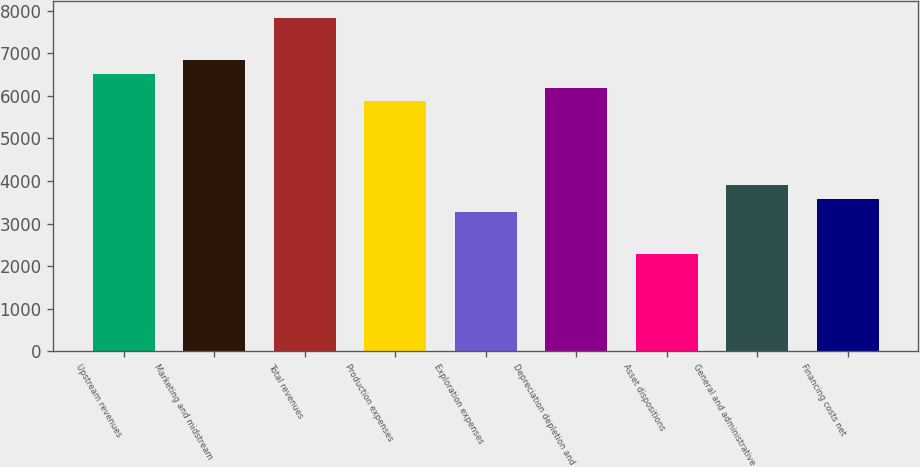<chart> <loc_0><loc_0><loc_500><loc_500><bar_chart><fcel>Upstream revenues<fcel>Marketing and midstream<fcel>Total revenues<fcel>Production expenses<fcel>Exploration expenses<fcel>Depreciation depletion and<fcel>Asset dispositions<fcel>General and administrative<fcel>Financing costs net<nl><fcel>6517.61<fcel>6843.47<fcel>7821.05<fcel>5865.89<fcel>3259.01<fcel>6191.75<fcel>2281.43<fcel>3910.73<fcel>3584.87<nl></chart> 